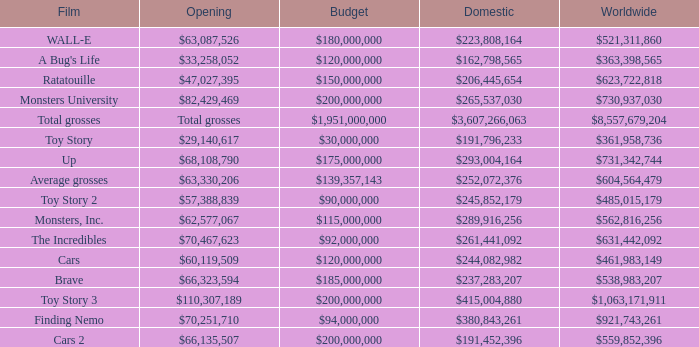WHAT IS THE BUDGET FOR THE INCREDIBLES? $92,000,000. 